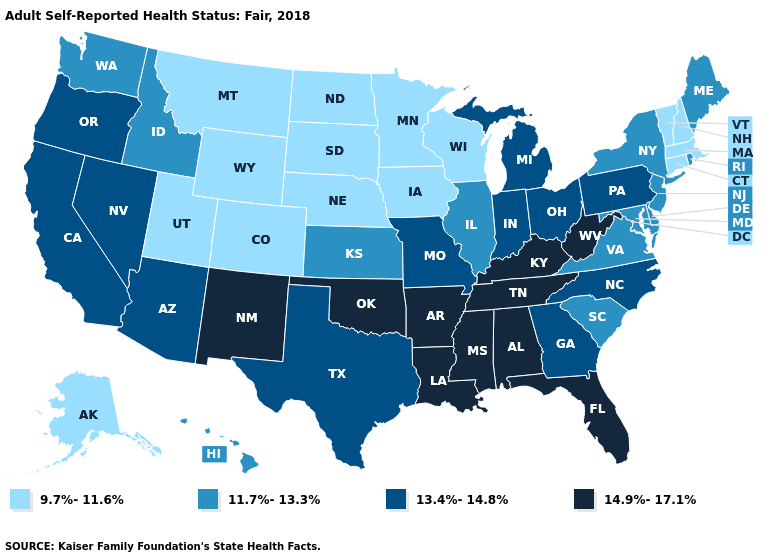Does Missouri have a lower value than Texas?
Quick response, please. No. What is the value of Oklahoma?
Answer briefly. 14.9%-17.1%. Which states have the highest value in the USA?
Keep it brief. Alabama, Arkansas, Florida, Kentucky, Louisiana, Mississippi, New Mexico, Oklahoma, Tennessee, West Virginia. Is the legend a continuous bar?
Short answer required. No. Among the states that border Minnesota , which have the lowest value?
Write a very short answer. Iowa, North Dakota, South Dakota, Wisconsin. Does the first symbol in the legend represent the smallest category?
Short answer required. Yes. Name the states that have a value in the range 14.9%-17.1%?
Write a very short answer. Alabama, Arkansas, Florida, Kentucky, Louisiana, Mississippi, New Mexico, Oklahoma, Tennessee, West Virginia. Does New Mexico have the highest value in the West?
Be succinct. Yes. Does Georgia have the highest value in the South?
Give a very brief answer. No. Among the states that border Vermont , which have the highest value?
Give a very brief answer. New York. Does the first symbol in the legend represent the smallest category?
Keep it brief. Yes. Does the map have missing data?
Be succinct. No. What is the value of West Virginia?
Write a very short answer. 14.9%-17.1%. 